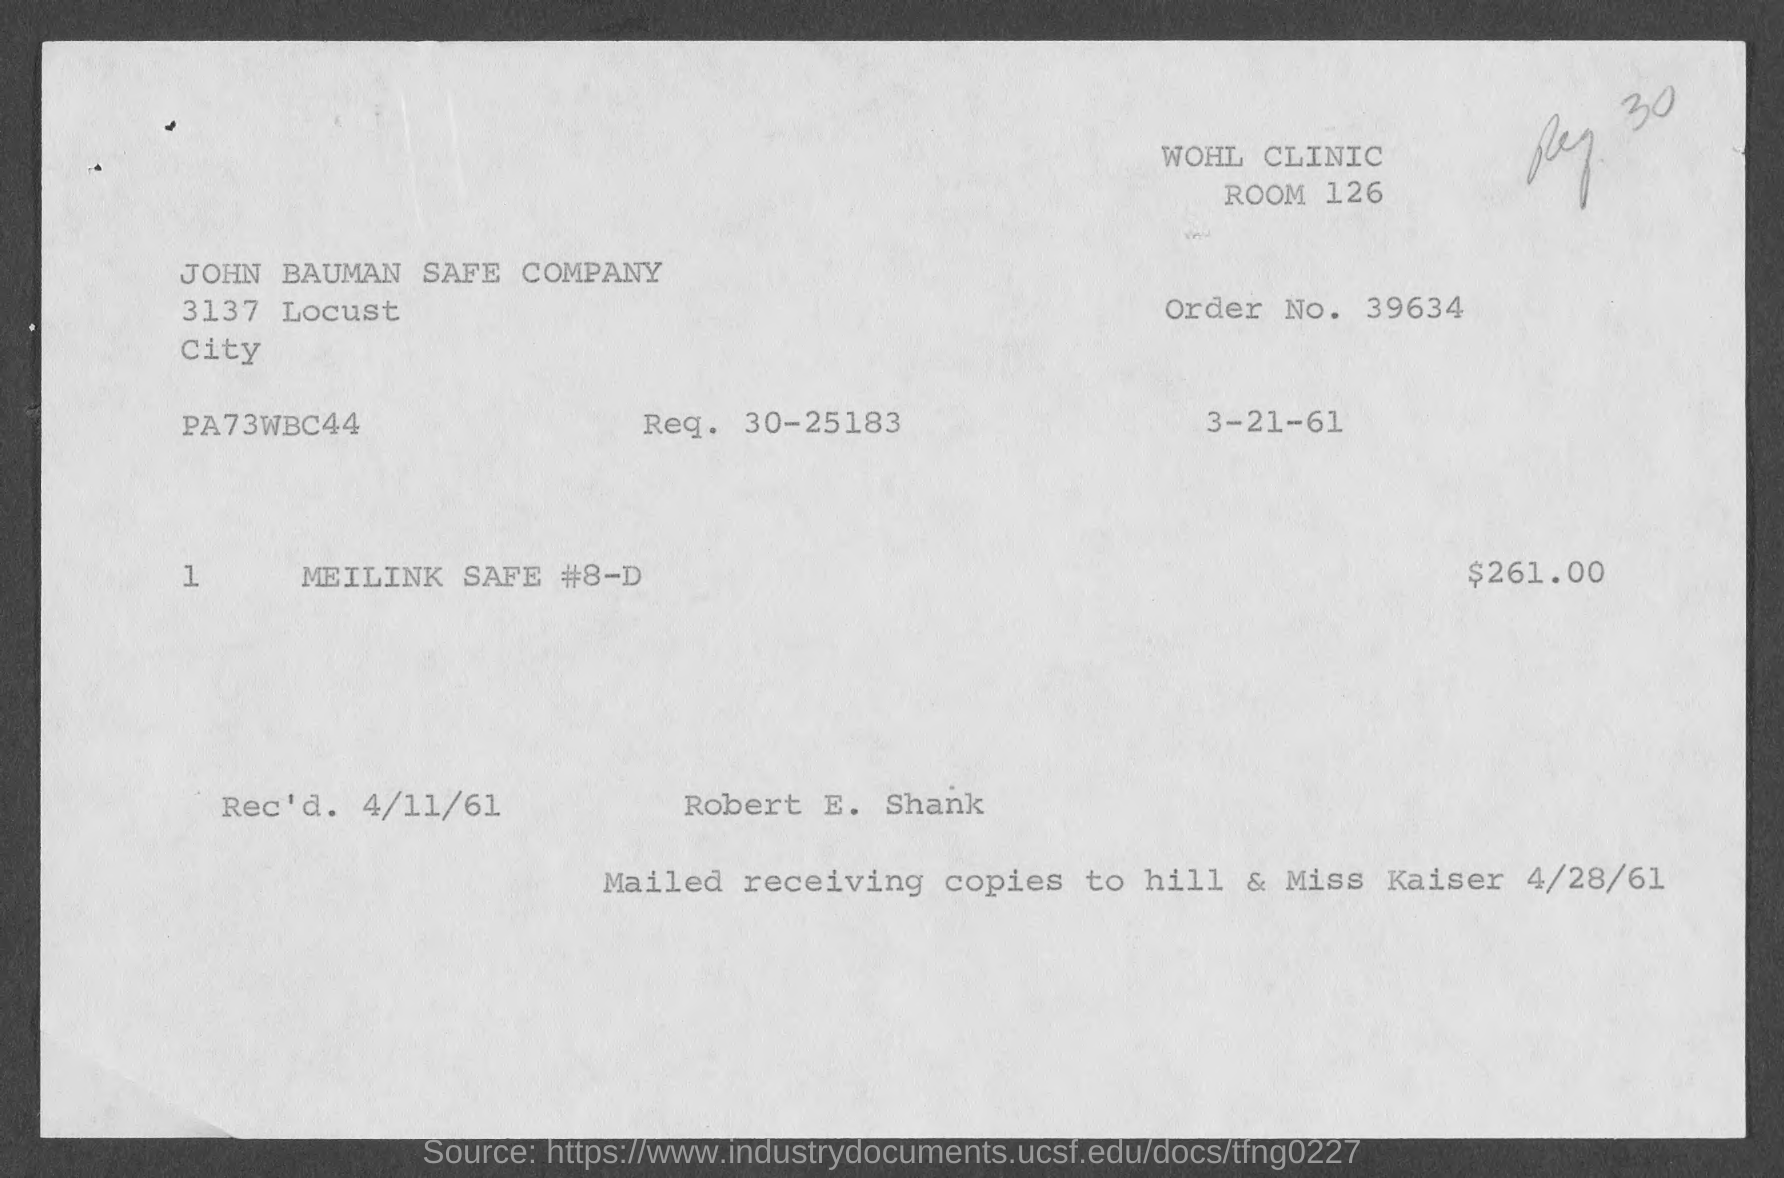What is the Room Number ?
Your answer should be compact. 126. What is the Order No. ?
Offer a very short reply. 39634. What is the Price ?
Ensure brevity in your answer.  261.00. What is the name of the company ?
Your answer should be very brief. John Bauman Safe Company. 